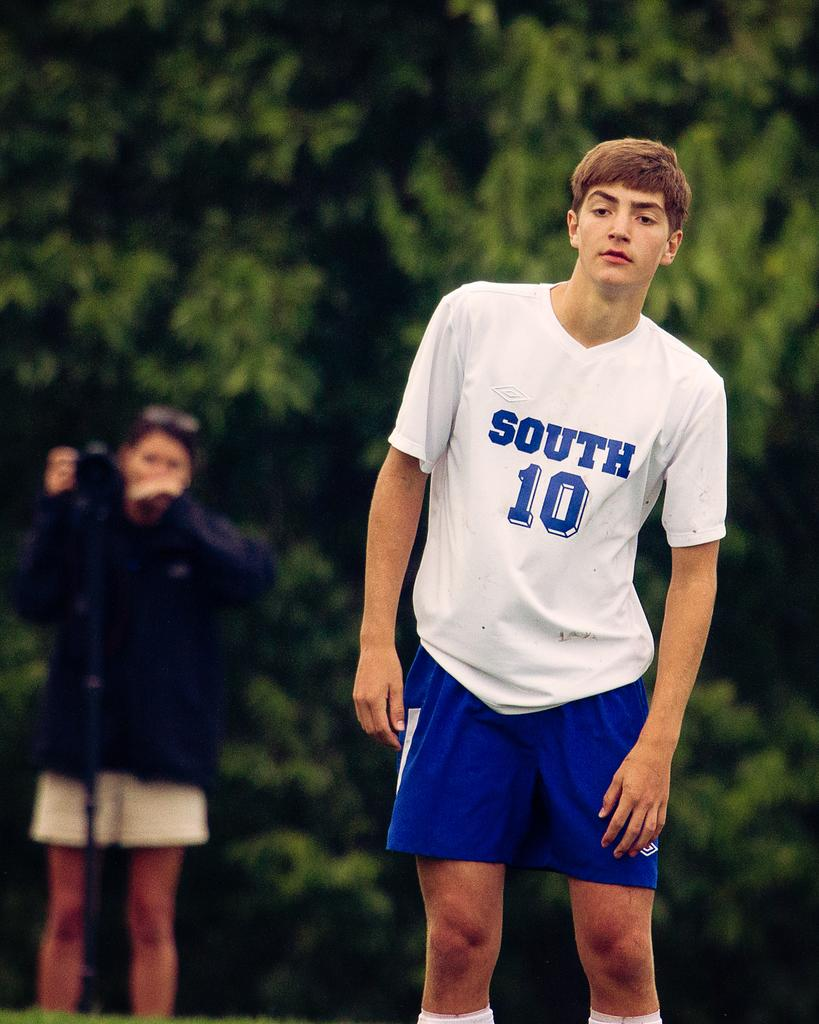<image>
Describe the image concisely. A soccer player wearing a blue and white jersey that says South 10 on it. 